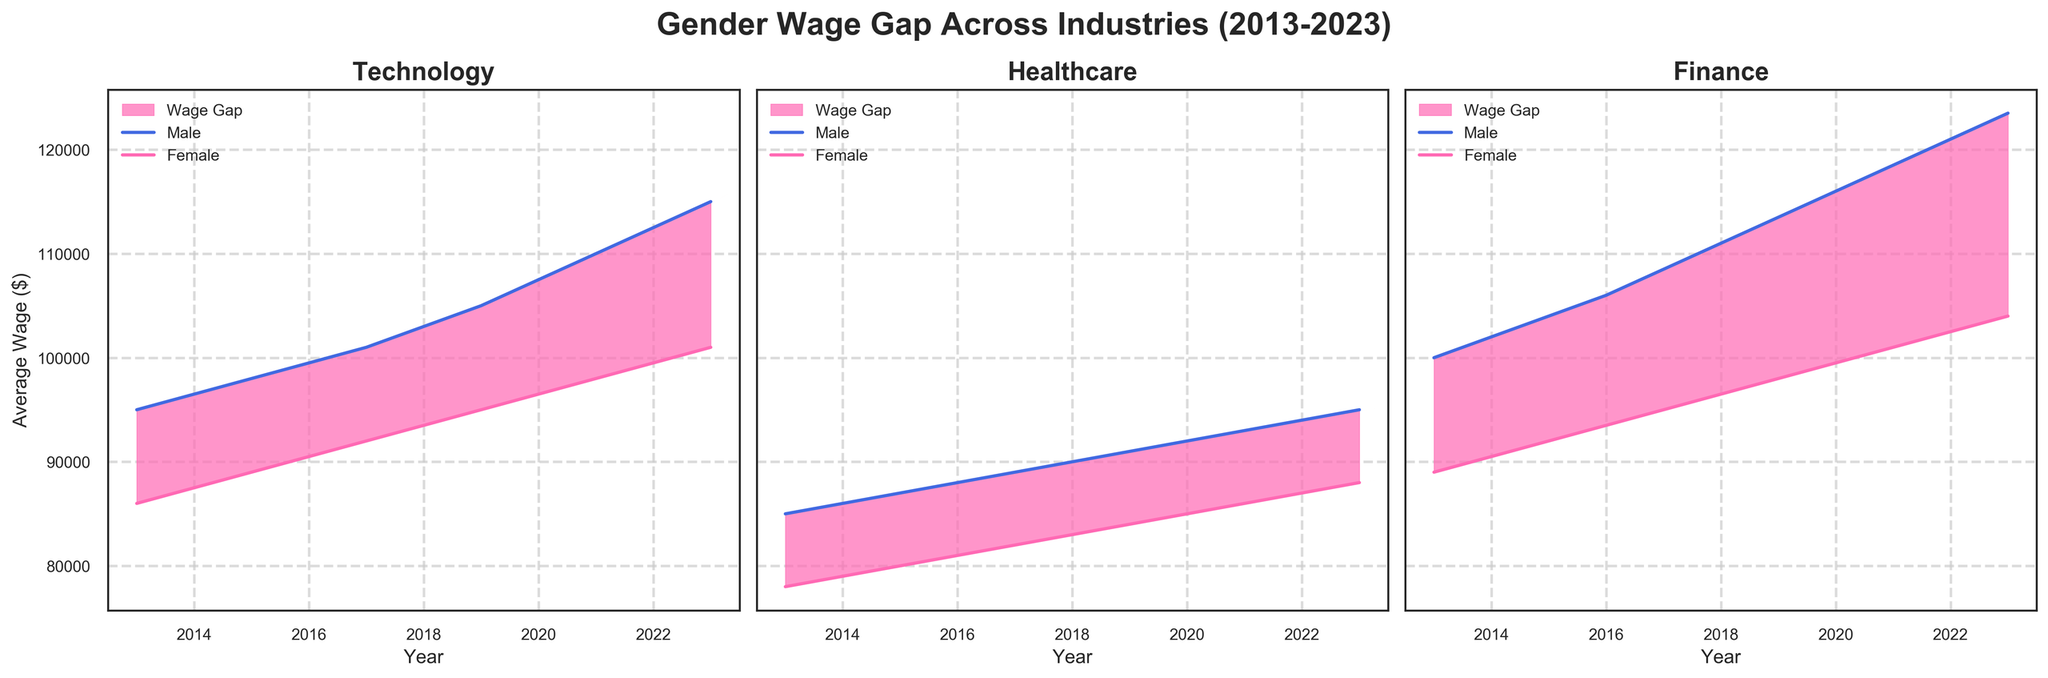What is the title of the figure? The title is given at the top center of the figure, which reads: "Gender Wage Gap Across Industries (2013-2023)", indicating the topic and the timeframe of the data.
Answer: Gender Wage Gap Across Industries (2013-2023) What do the colors in the plots represent? The colors in the plots represent different genders and the wage gap: the line in blue represents male wages, the line in pink represents female wages, and the filled area represents the wage gap.
Answer: Blue represents male wages, pink represents female wages, and the filled area represents the wage gap Which industry shows the largest wage gap between males and females in 2023? By looking at the rightmost part of each subplot in 2023, Finance has the largest difference between the male and female wage lines, indicating the largest wage gap.
Answer: Finance How has the wage gap in the Technology industry changed from 2013 to 2023? Observing the filled area between the male and female wage lines in the Technology subplot, the wage gap has slightly decreased over the years since the area seems to decrease marginally.
Answer: Decreased slightly Compare the wage growth for females in the Healthcare and Finance industries from 2013 to 2023. For females, the wage in Healthcare increases from $78,000 to $88,000, a difference of $10,000. In Finance, it increases from $89,000 to $104,000, a difference of $15,000. Finance shows a greater increase.
Answer: Finance shows a greater increase In which year was the wage gap in the Healthcare industry the smallest? By examining the subplot for Healthcare and finding the year with the smallest filled area, it's around 2023, where the difference between male and female wage lines seems smallest.
Answer: 2023 What was the average wage for males in the Technology industry in 2019? The plot shows the male wage line at around $105,000 in 2019, as indicated by the value on the y-axis directly under that year.
Answer: $105,000 Compare male wages between the Technology and Finance industries in 2020. By looking vertically at the year 2020 in both subplots, male wages in Technology are around $107,500 and in Finance are around $116,000. Finance male wages are higher.
Answer: Finance male wages are higher How do the female wage growth trends compare across the industries from 2013 to 2023? Observing the lines representing female wages, all three industries show an upward trend, but the slopes differ. The Finance industry shows the steepest increase while Healthcare shows the slowest.
Answer: Finance shows the steepest increase, Healthcare the slowest Can you identify any industries where the wage gap has remained relatively constant over the past decade? By looking for minimal changes in the area between male and female wage lines over the years, Healthcare shows a relatively stable gap with minimal fluctuations.
Answer: Healthcare 